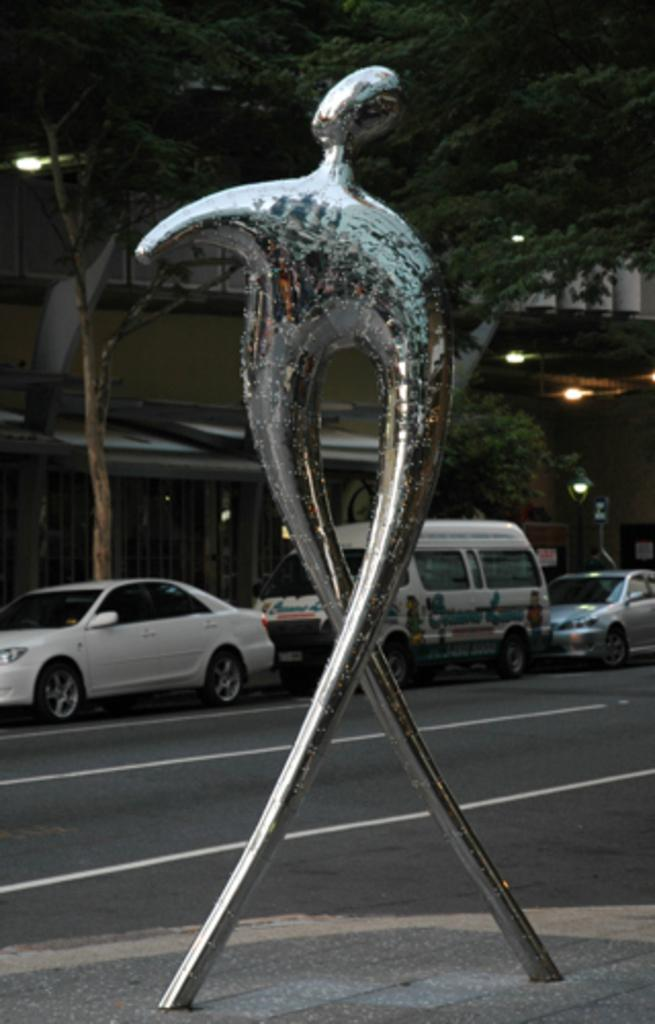What is the main subject of the image? There is an iconic model on the road. What else can be seen beside the road? There are vehicles parked beside the road. What type of natural elements are present in the image? There are trees in the image. What type of man-made structures can be seen in the image? There are houses in the image. What type of ring can be seen on the face of the model in the image? There is no ring or face visible in the image; it only shows an iconic model on the road. 